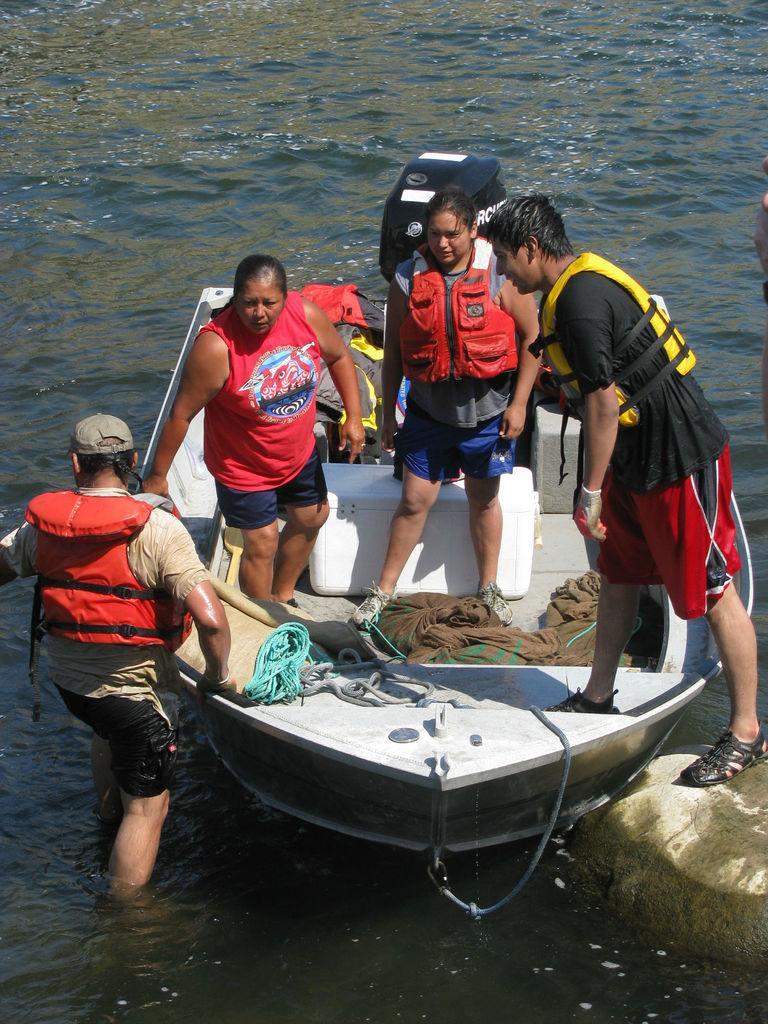How would you summarize this image in a sentence or two? There are people standing and we can see boat above the water and we can see ropes and clothes on a boat. 